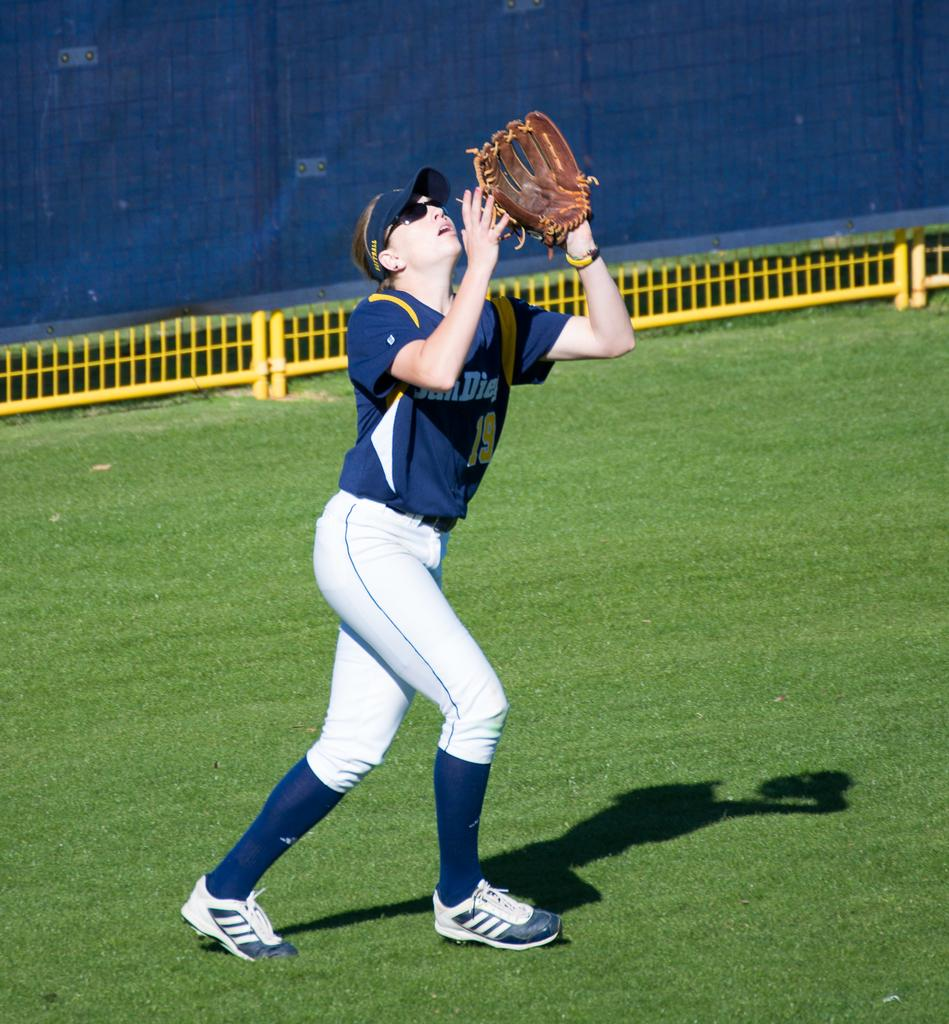<image>
Present a compact description of the photo's key features. Baseball player wearing a jersey that says San Diego on it. 